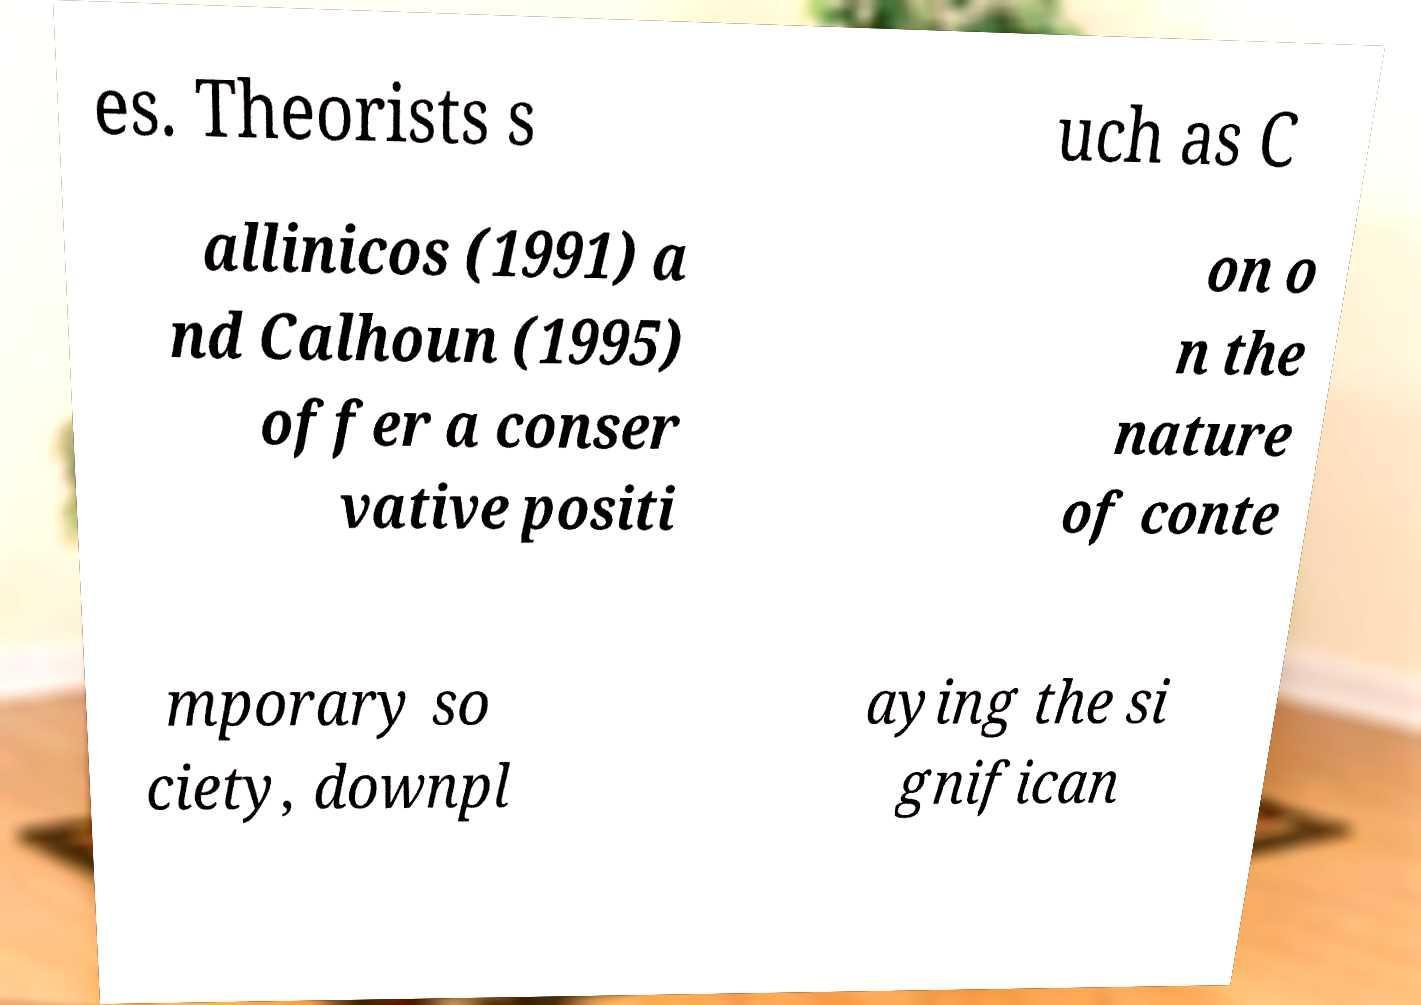Can you accurately transcribe the text from the provided image for me? es. Theorists s uch as C allinicos (1991) a nd Calhoun (1995) offer a conser vative positi on o n the nature of conte mporary so ciety, downpl aying the si gnifican 